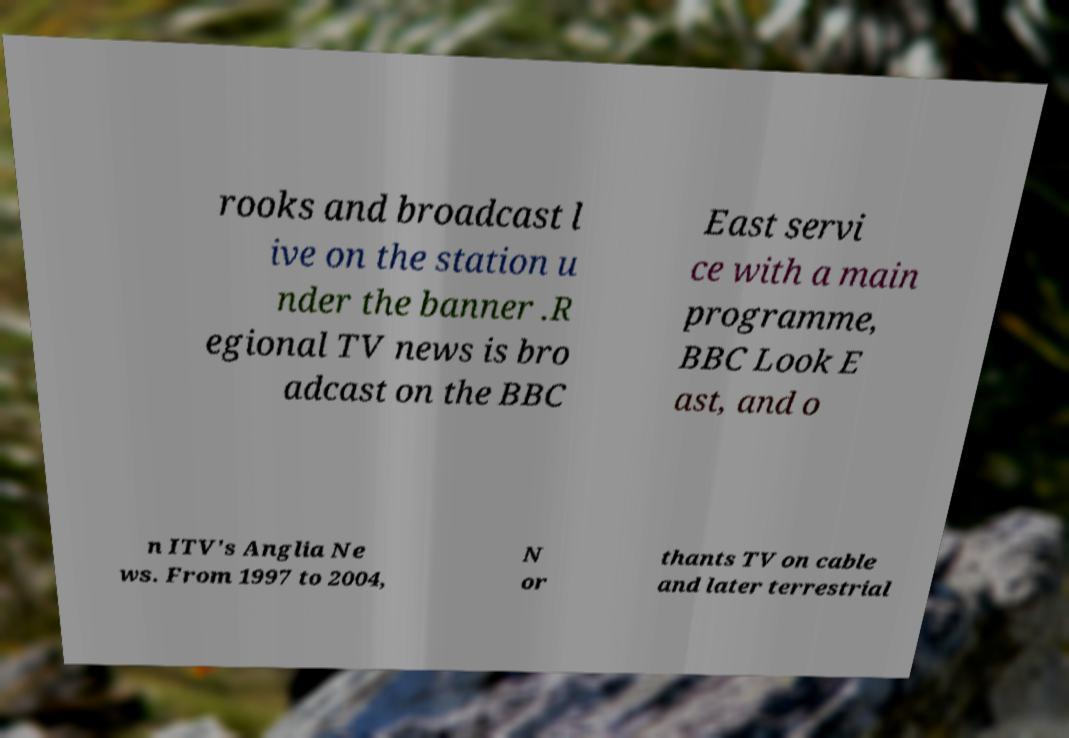Could you extract and type out the text from this image? rooks and broadcast l ive on the station u nder the banner .R egional TV news is bro adcast on the BBC East servi ce with a main programme, BBC Look E ast, and o n ITV's Anglia Ne ws. From 1997 to 2004, N or thants TV on cable and later terrestrial 